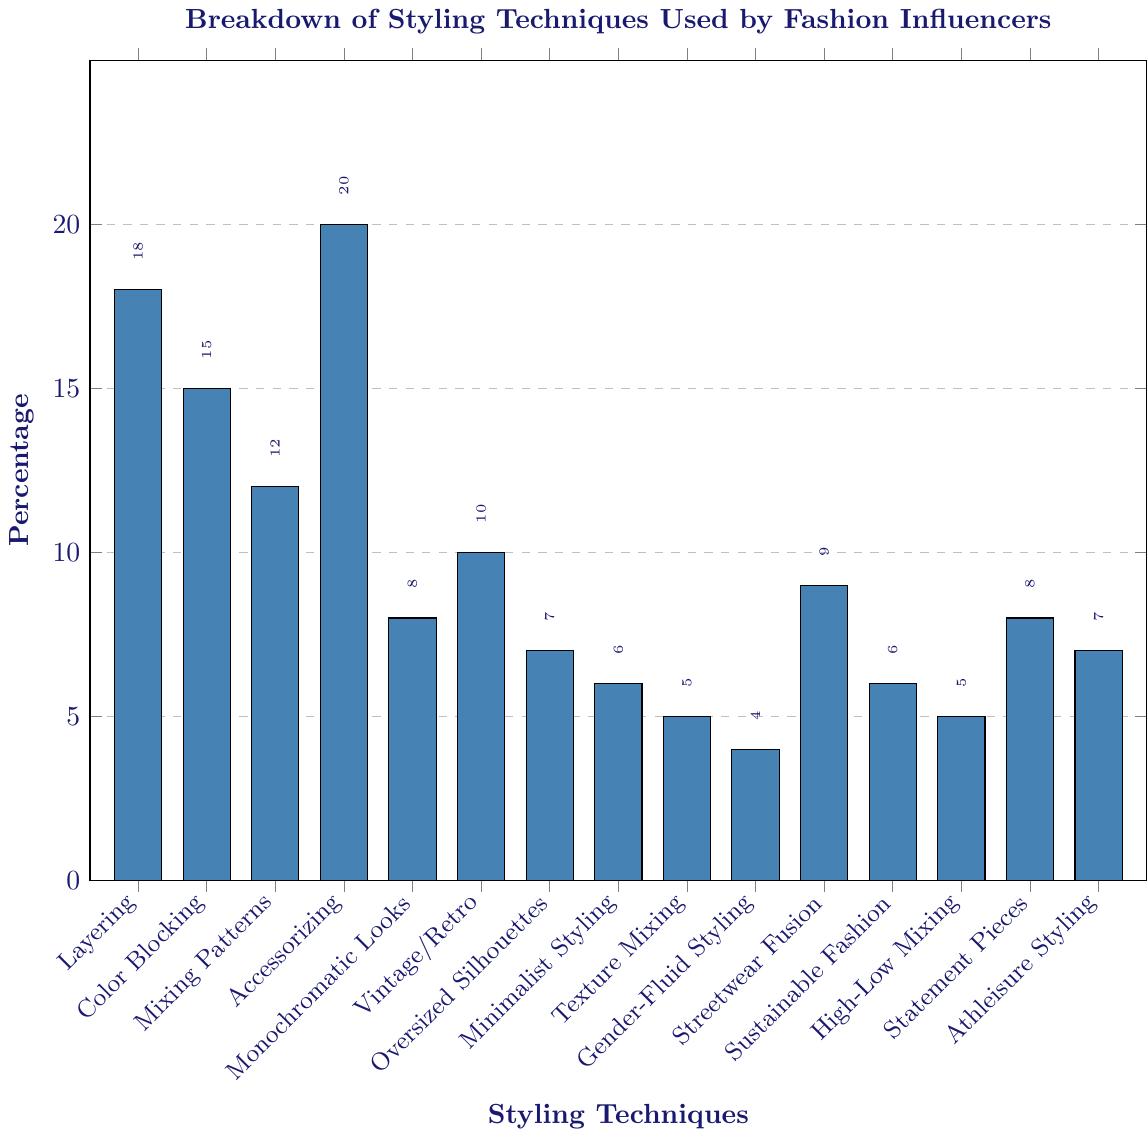What is the highest percentage technique used by fashion influencers? The highest bar on the chart represents the most used technique by fashion influencers, which is Accessorizing at 20%.
Answer: Accessorizing Which styling technique has the lowest percentage usage among fashion influencers? The smallest bar, representing the lowest percentage, corresponds to Gender-Fluid Styling at 4%.
Answer: Gender-Fluid Styling Compare the usage percentage between Layering and Monochromatic Looks. Which technique is used more, and by how much? The bar representing Layering has a percentage of 18%, while Monochromatic Looks has a percentage of 8%. The difference is 18% - 8% = 10%.
Answer: Layering by 10% Calculate the total percentage of usage for texture-related styling techniques, specifically, Texture Mixing and Mixing Patterns. Texture Mixing is 5%, and Mixing Patterns is 12%. Summing them up results in 5% + 12% = 17%.
Answer: 17% How does the popularity of Sustainable Fashion compare to Minimalist Styling in terms of percentage? Sustainable Fashion and Minimalist Styling both share a percentage of 6%, making their usage equal.
Answer: Equal Which two techniques have the same usage percentage according to the chart? By examining the heights of the bars, Minimalist Styling and Sustainable Fashion both have a percentage of 6%.
Answer: Minimalist Styling and Sustainable Fashion What is the median percentage value of all the styling techniques listed on the chart? To find the median, we first list the percentages in ascending order: 4, 5, 5, 6, 6, 7, 7, 8, 8, 9, 10, 12, 15, 18, 20. The median value is the middle value in this ordered list, which is 8%.
Answer: 8% What percentage more is Color Blocking used compared to Minimalist Styling? Color Blocking is used 15%, while Minimalist Styling is used 6%. The difference is 15% - 6% = 9%.
Answer: 9% Identify the three least utilized styling techniques and their combined percentage. The three smallest bars correspond to Gender-Fluid Styling (4%), Texture Mixing (5%), and High-Low Mixing (5%). Adding them: 4% + 5% + 5% = 14%.
Answer: 14% How much more popular is Accessorizing than Athleisure Styling? Accessorizing has a percentage of 20%, and Athleisure Styling has 7%. The difference is 20% - 7% = 13%.
Answer: 13% 